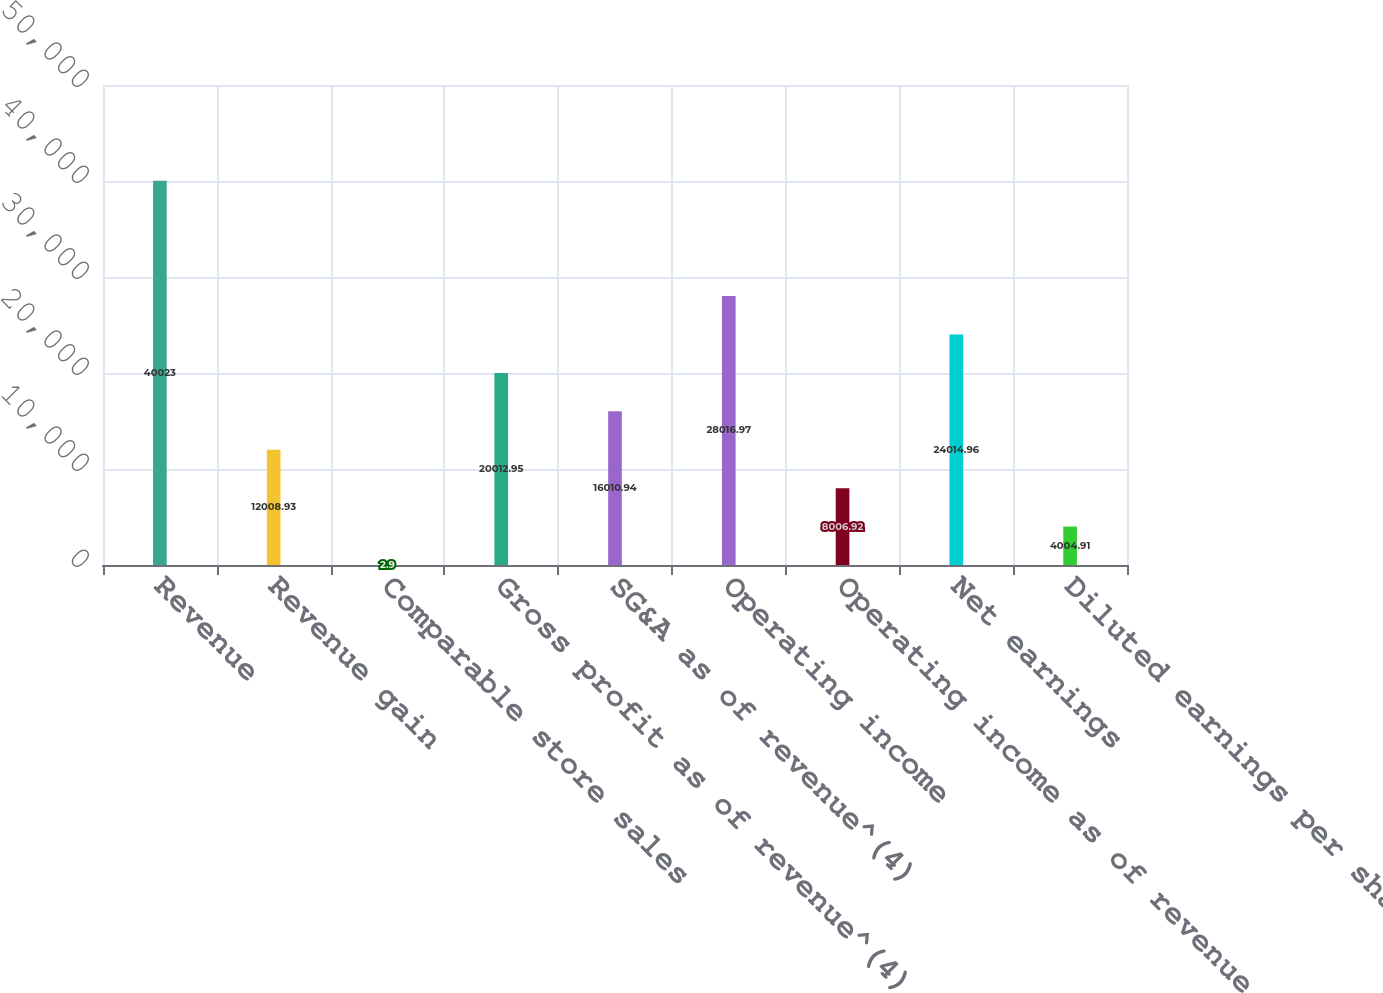Convert chart to OTSL. <chart><loc_0><loc_0><loc_500><loc_500><bar_chart><fcel>Revenue<fcel>Revenue gain<fcel>Comparable store sales<fcel>Gross profit as of revenue^(4)<fcel>SG&A as of revenue^(4)<fcel>Operating income<fcel>Operating income as of revenue<fcel>Net earnings<fcel>Diluted earnings per share<nl><fcel>40023<fcel>12008.9<fcel>2.9<fcel>20013<fcel>16010.9<fcel>28017<fcel>8006.92<fcel>24015<fcel>4004.91<nl></chart> 